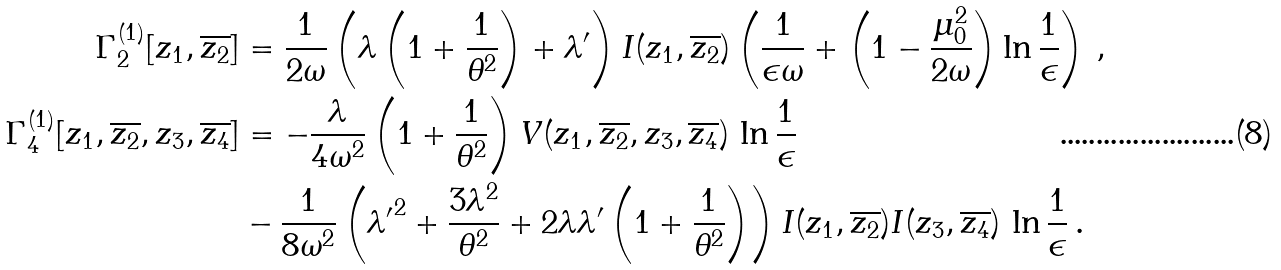<formula> <loc_0><loc_0><loc_500><loc_500>\Gamma ^ { ( 1 ) } _ { 2 } [ z _ { 1 } , \overline { z _ { 2 } } ] & = \frac { 1 } { 2 \omega } \left ( \lambda \left ( 1 + \frac { 1 } { \theta ^ { 2 } } \right ) + \lambda ^ { \prime } \right ) I ( z _ { 1 } , \overline { z _ { 2 } } ) \left ( \frac { 1 } { \epsilon \omega } + \left ( 1 - \frac { \mu _ { 0 } ^ { 2 } } { 2 \omega } \right ) \ln \frac { 1 } { \epsilon } \right ) \, , \\ \Gamma ^ { ( 1 ) } _ { 4 } [ z _ { 1 } , \overline { z _ { 2 } } , z _ { 3 } , \overline { z _ { 4 } } ] & = - \frac { \lambda } { 4 \omega ^ { 2 } } \left ( 1 + \frac { 1 } { \theta ^ { 2 } } \right ) V ( z _ { 1 } , \overline { z _ { 2 } } , z _ { 3 } , \overline { z _ { 4 } } ) \, \ln \frac { 1 } { \epsilon } \\ & - \frac { 1 } { 8 \omega ^ { 2 } } \left ( { \lambda ^ { \prime } } ^ { 2 } + \frac { 3 \lambda ^ { 2 } } { \theta ^ { 2 } } + 2 \lambda \lambda ^ { \prime } \left ( 1 + \frac { 1 } { \theta ^ { 2 } } \right ) \right ) I ( z _ { 1 } , \overline { z _ { 2 } } ) I ( z _ { 3 } , \overline { z _ { 4 } } ) \, \ln \frac { 1 } { \epsilon } \, .</formula> 